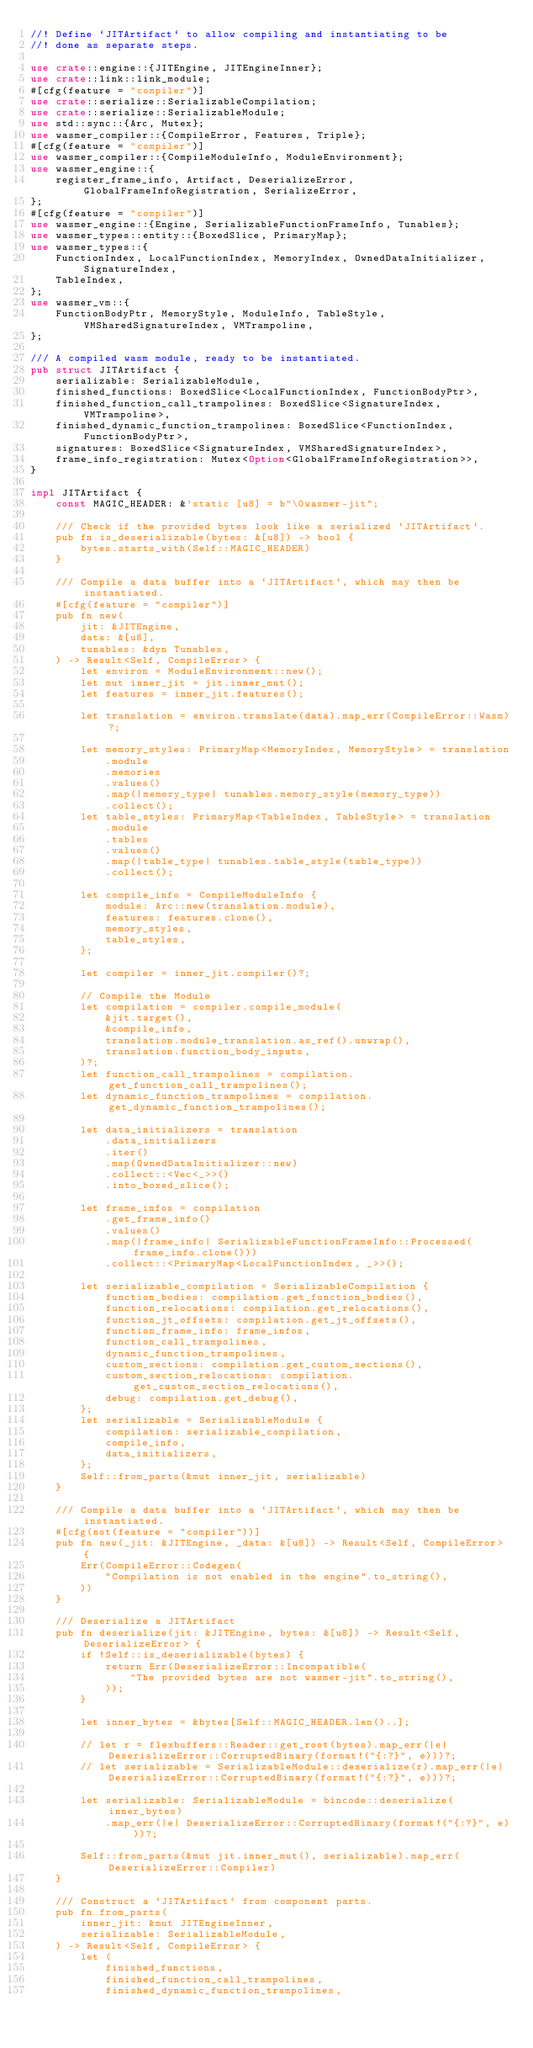Convert code to text. <code><loc_0><loc_0><loc_500><loc_500><_Rust_>//! Define `JITArtifact` to allow compiling and instantiating to be
//! done as separate steps.

use crate::engine::{JITEngine, JITEngineInner};
use crate::link::link_module;
#[cfg(feature = "compiler")]
use crate::serialize::SerializableCompilation;
use crate::serialize::SerializableModule;
use std::sync::{Arc, Mutex};
use wasmer_compiler::{CompileError, Features, Triple};
#[cfg(feature = "compiler")]
use wasmer_compiler::{CompileModuleInfo, ModuleEnvironment};
use wasmer_engine::{
    register_frame_info, Artifact, DeserializeError, GlobalFrameInfoRegistration, SerializeError,
};
#[cfg(feature = "compiler")]
use wasmer_engine::{Engine, SerializableFunctionFrameInfo, Tunables};
use wasmer_types::entity::{BoxedSlice, PrimaryMap};
use wasmer_types::{
    FunctionIndex, LocalFunctionIndex, MemoryIndex, OwnedDataInitializer, SignatureIndex,
    TableIndex,
};
use wasmer_vm::{
    FunctionBodyPtr, MemoryStyle, ModuleInfo, TableStyle, VMSharedSignatureIndex, VMTrampoline,
};

/// A compiled wasm module, ready to be instantiated.
pub struct JITArtifact {
    serializable: SerializableModule,
    finished_functions: BoxedSlice<LocalFunctionIndex, FunctionBodyPtr>,
    finished_function_call_trampolines: BoxedSlice<SignatureIndex, VMTrampoline>,
    finished_dynamic_function_trampolines: BoxedSlice<FunctionIndex, FunctionBodyPtr>,
    signatures: BoxedSlice<SignatureIndex, VMSharedSignatureIndex>,
    frame_info_registration: Mutex<Option<GlobalFrameInfoRegistration>>,
}

impl JITArtifact {
    const MAGIC_HEADER: &'static [u8] = b"\0wasmer-jit";

    /// Check if the provided bytes look like a serialized `JITArtifact`.
    pub fn is_deserializable(bytes: &[u8]) -> bool {
        bytes.starts_with(Self::MAGIC_HEADER)
    }

    /// Compile a data buffer into a `JITArtifact`, which may then be instantiated.
    #[cfg(feature = "compiler")]
    pub fn new(
        jit: &JITEngine,
        data: &[u8],
        tunables: &dyn Tunables,
    ) -> Result<Self, CompileError> {
        let environ = ModuleEnvironment::new();
        let mut inner_jit = jit.inner_mut();
        let features = inner_jit.features();

        let translation = environ.translate(data).map_err(CompileError::Wasm)?;

        let memory_styles: PrimaryMap<MemoryIndex, MemoryStyle> = translation
            .module
            .memories
            .values()
            .map(|memory_type| tunables.memory_style(memory_type))
            .collect();
        let table_styles: PrimaryMap<TableIndex, TableStyle> = translation
            .module
            .tables
            .values()
            .map(|table_type| tunables.table_style(table_type))
            .collect();

        let compile_info = CompileModuleInfo {
            module: Arc::new(translation.module),
            features: features.clone(),
            memory_styles,
            table_styles,
        };

        let compiler = inner_jit.compiler()?;

        // Compile the Module
        let compilation = compiler.compile_module(
            &jit.target(),
            &compile_info,
            translation.module_translation.as_ref().unwrap(),
            translation.function_body_inputs,
        )?;
        let function_call_trampolines = compilation.get_function_call_trampolines();
        let dynamic_function_trampolines = compilation.get_dynamic_function_trampolines();

        let data_initializers = translation
            .data_initializers
            .iter()
            .map(OwnedDataInitializer::new)
            .collect::<Vec<_>>()
            .into_boxed_slice();

        let frame_infos = compilation
            .get_frame_info()
            .values()
            .map(|frame_info| SerializableFunctionFrameInfo::Processed(frame_info.clone()))
            .collect::<PrimaryMap<LocalFunctionIndex, _>>();

        let serializable_compilation = SerializableCompilation {
            function_bodies: compilation.get_function_bodies(),
            function_relocations: compilation.get_relocations(),
            function_jt_offsets: compilation.get_jt_offsets(),
            function_frame_info: frame_infos,
            function_call_trampolines,
            dynamic_function_trampolines,
            custom_sections: compilation.get_custom_sections(),
            custom_section_relocations: compilation.get_custom_section_relocations(),
            debug: compilation.get_debug(),
        };
        let serializable = SerializableModule {
            compilation: serializable_compilation,
            compile_info,
            data_initializers,
        };
        Self::from_parts(&mut inner_jit, serializable)
    }

    /// Compile a data buffer into a `JITArtifact`, which may then be instantiated.
    #[cfg(not(feature = "compiler"))]
    pub fn new(_jit: &JITEngine, _data: &[u8]) -> Result<Self, CompileError> {
        Err(CompileError::Codegen(
            "Compilation is not enabled in the engine".to_string(),
        ))
    }

    /// Deserialize a JITArtifact
    pub fn deserialize(jit: &JITEngine, bytes: &[u8]) -> Result<Self, DeserializeError> {
        if !Self::is_deserializable(bytes) {
            return Err(DeserializeError::Incompatible(
                "The provided bytes are not wasmer-jit".to_string(),
            ));
        }

        let inner_bytes = &bytes[Self::MAGIC_HEADER.len()..];

        // let r = flexbuffers::Reader::get_root(bytes).map_err(|e| DeserializeError::CorruptedBinary(format!("{:?}", e)))?;
        // let serializable = SerializableModule::deserialize(r).map_err(|e| DeserializeError::CorruptedBinary(format!("{:?}", e)))?;

        let serializable: SerializableModule = bincode::deserialize(inner_bytes)
            .map_err(|e| DeserializeError::CorruptedBinary(format!("{:?}", e)))?;

        Self::from_parts(&mut jit.inner_mut(), serializable).map_err(DeserializeError::Compiler)
    }

    /// Construct a `JITArtifact` from component parts.
    pub fn from_parts(
        inner_jit: &mut JITEngineInner,
        serializable: SerializableModule,
    ) -> Result<Self, CompileError> {
        let (
            finished_functions,
            finished_function_call_trampolines,
            finished_dynamic_function_trampolines,</code> 